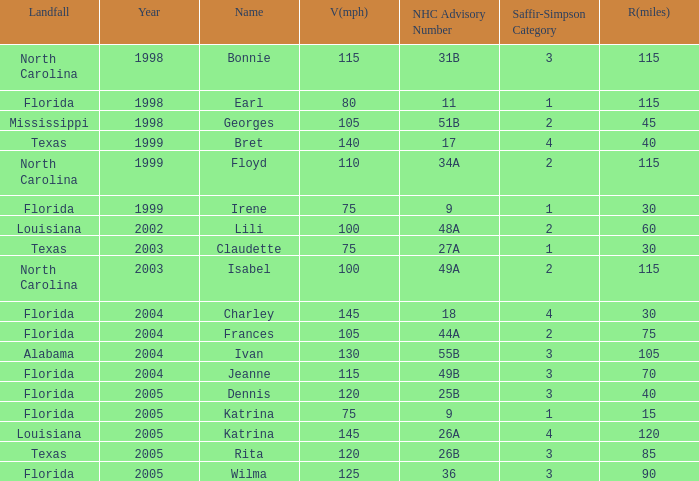What was the lowest V(mph) for a Saffir-Simpson of 4 in 2005? 145.0. 